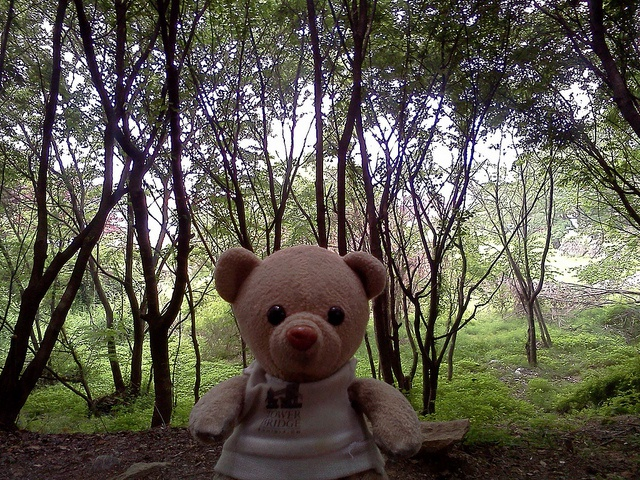Describe the objects in this image and their specific colors. I can see a teddy bear in darkgreen, black, gray, and maroon tones in this image. 